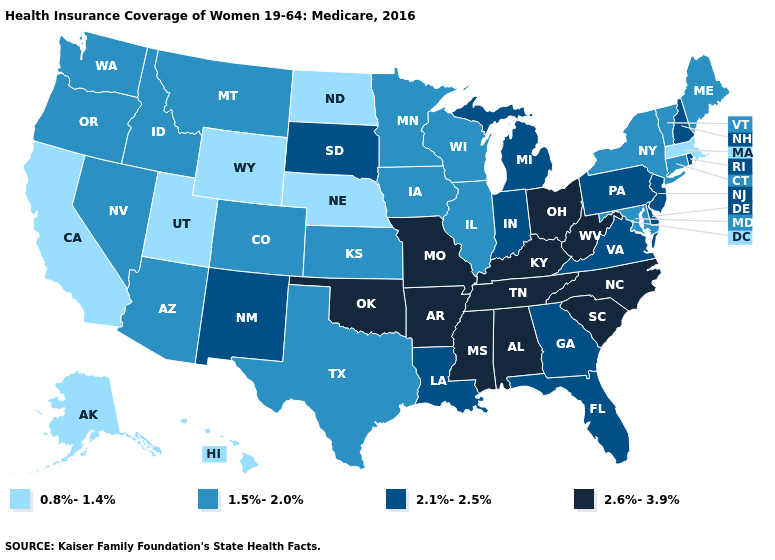Does Kansas have a lower value than North Dakota?
Give a very brief answer. No. What is the lowest value in states that border Pennsylvania?
Answer briefly. 1.5%-2.0%. Does North Carolina have the highest value in the South?
Answer briefly. Yes. Among the states that border Connecticut , does Massachusetts have the lowest value?
Short answer required. Yes. What is the highest value in states that border Maine?
Give a very brief answer. 2.1%-2.5%. Name the states that have a value in the range 1.5%-2.0%?
Be succinct. Arizona, Colorado, Connecticut, Idaho, Illinois, Iowa, Kansas, Maine, Maryland, Minnesota, Montana, Nevada, New York, Oregon, Texas, Vermont, Washington, Wisconsin. What is the value of Alabama?
Be succinct. 2.6%-3.9%. Name the states that have a value in the range 1.5%-2.0%?
Answer briefly. Arizona, Colorado, Connecticut, Idaho, Illinois, Iowa, Kansas, Maine, Maryland, Minnesota, Montana, Nevada, New York, Oregon, Texas, Vermont, Washington, Wisconsin. Does Florida have a lower value than Rhode Island?
Short answer required. No. What is the lowest value in the West?
Write a very short answer. 0.8%-1.4%. Does the map have missing data?
Quick response, please. No. What is the highest value in the West ?
Write a very short answer. 2.1%-2.5%. Does Washington have the same value as Maine?
Keep it brief. Yes. Does Texas have the lowest value in the South?
Give a very brief answer. Yes. Name the states that have a value in the range 1.5%-2.0%?
Give a very brief answer. Arizona, Colorado, Connecticut, Idaho, Illinois, Iowa, Kansas, Maine, Maryland, Minnesota, Montana, Nevada, New York, Oregon, Texas, Vermont, Washington, Wisconsin. 